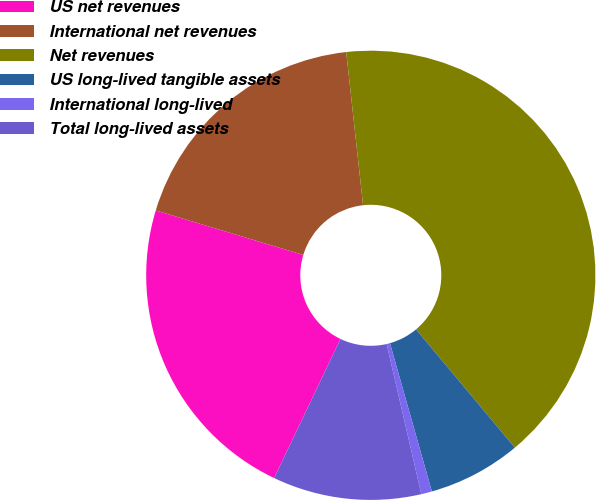<chart> <loc_0><loc_0><loc_500><loc_500><pie_chart><fcel>US net revenues<fcel>International net revenues<fcel>Net revenues<fcel>US long-lived tangible assets<fcel>International long-lived<fcel>Total long-lived assets<nl><fcel>22.58%<fcel>18.59%<fcel>40.66%<fcel>6.7%<fcel>0.77%<fcel>10.69%<nl></chart> 